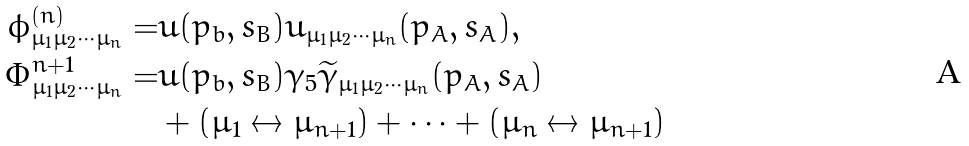Convert formula to latex. <formula><loc_0><loc_0><loc_500><loc_500>\phi ^ { ( n ) } _ { \mu _ { 1 } \mu _ { 2 } \cdots \mu _ { n } } = & \bar { u } ( p _ { b } , s _ { B } ) u _ { \mu _ { 1 } \mu _ { 2 } \cdots \mu _ { n } } ( p _ { A } , s _ { A } ) , \\ \Phi ^ { n + 1 } _ { \mu _ { 1 } \mu _ { 2 } \cdots \mu _ { n } } = & \bar { u } ( p _ { b } , s _ { B } ) \gamma _ { 5 } \widetilde { \gamma } _ { \mu _ { 1 } \mu _ { 2 } \cdots \mu _ { n } } ( p _ { A } , s _ { A } ) \\ & + ( \mu _ { 1 } \leftrightarrow \mu _ { n + 1 } ) + \cdots + ( \mu _ { n } \leftrightarrow \mu _ { n + 1 } )</formula> 